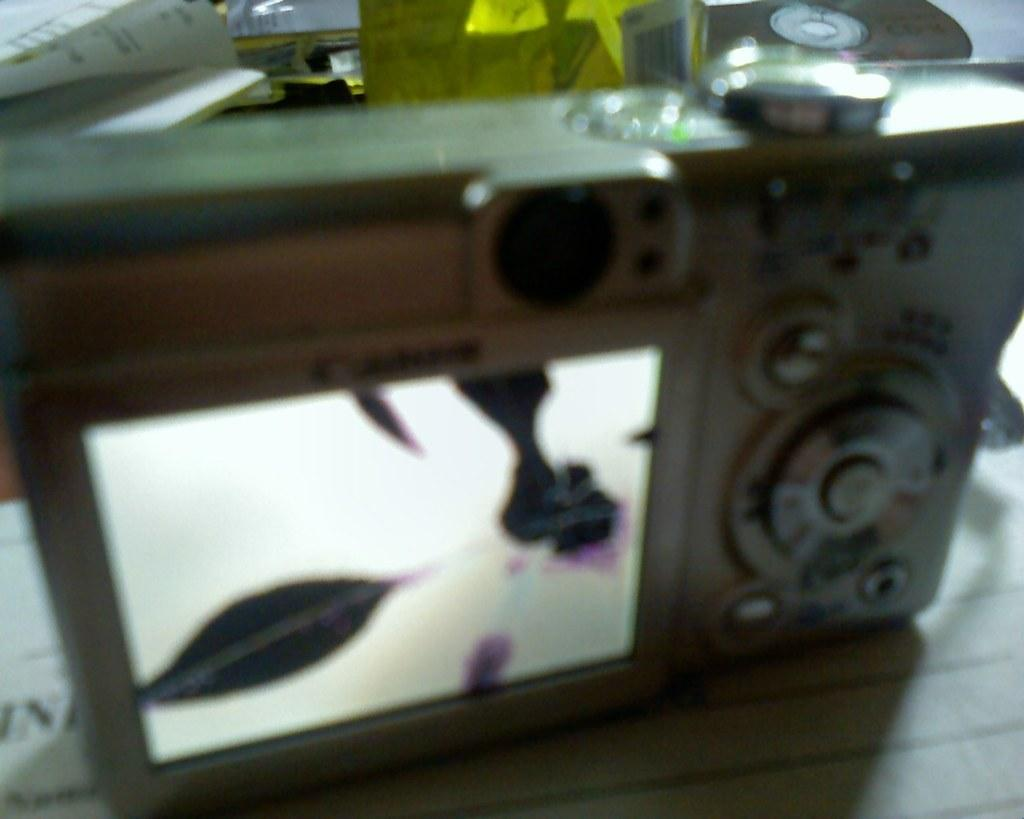What is the main object in the image? There is a camera in the image. What features does the camera have? The camera has a screen and buttons. Can you describe a specific button on the camera? There is an adjuster button on top of the camera. What else can be seen in the image besides the camera? Papers are visible behind the camera. What type of pail is being used to skate downtown in the image? There is no pail, skating, or downtown location present in the image; it features a camera with various buttons and a screen. 